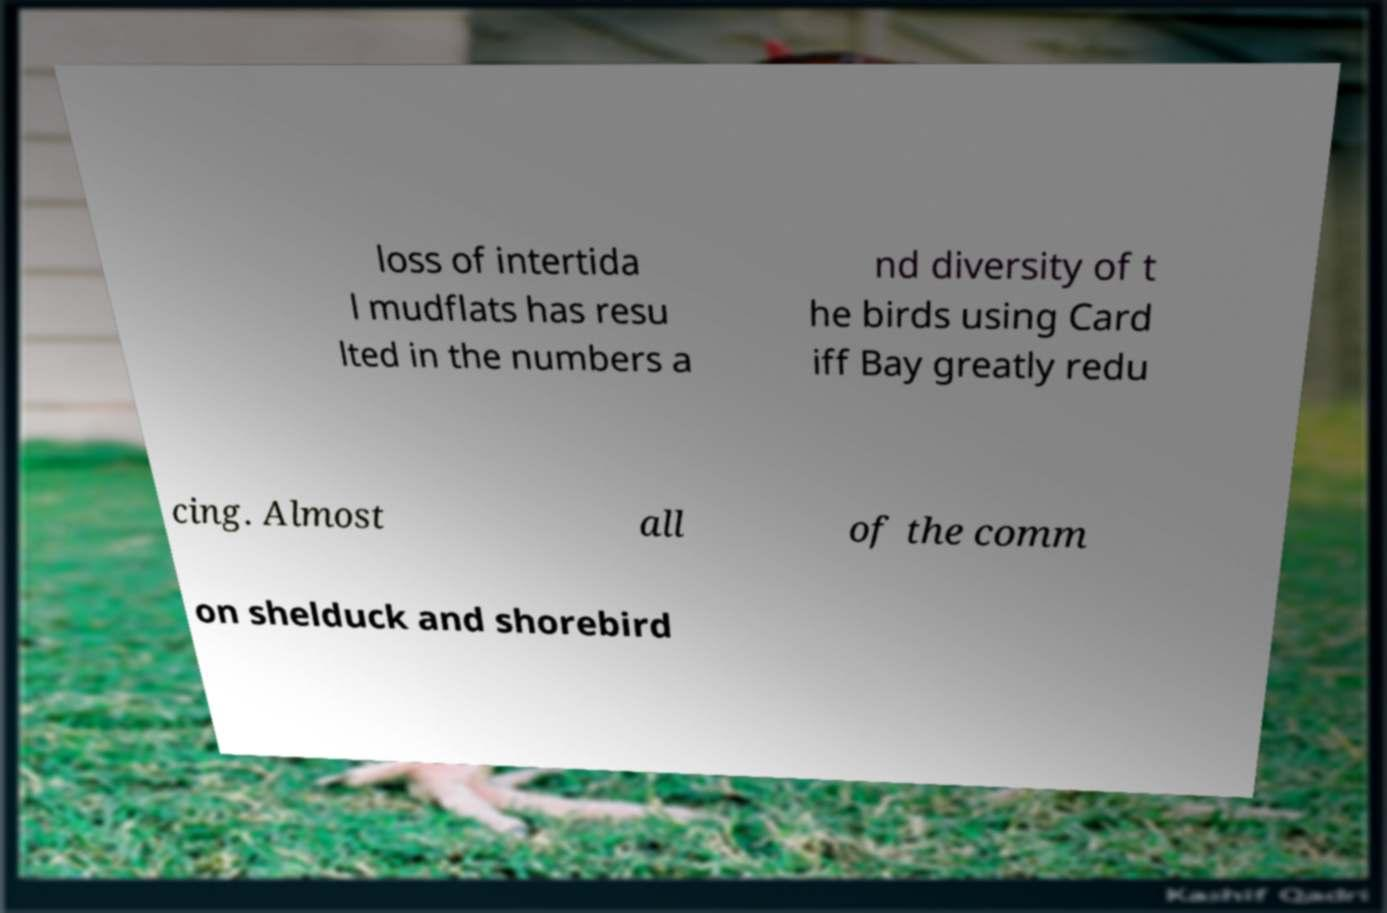For documentation purposes, I need the text within this image transcribed. Could you provide that? loss of intertida l mudflats has resu lted in the numbers a nd diversity of t he birds using Card iff Bay greatly redu cing. Almost all of the comm on shelduck and shorebird 